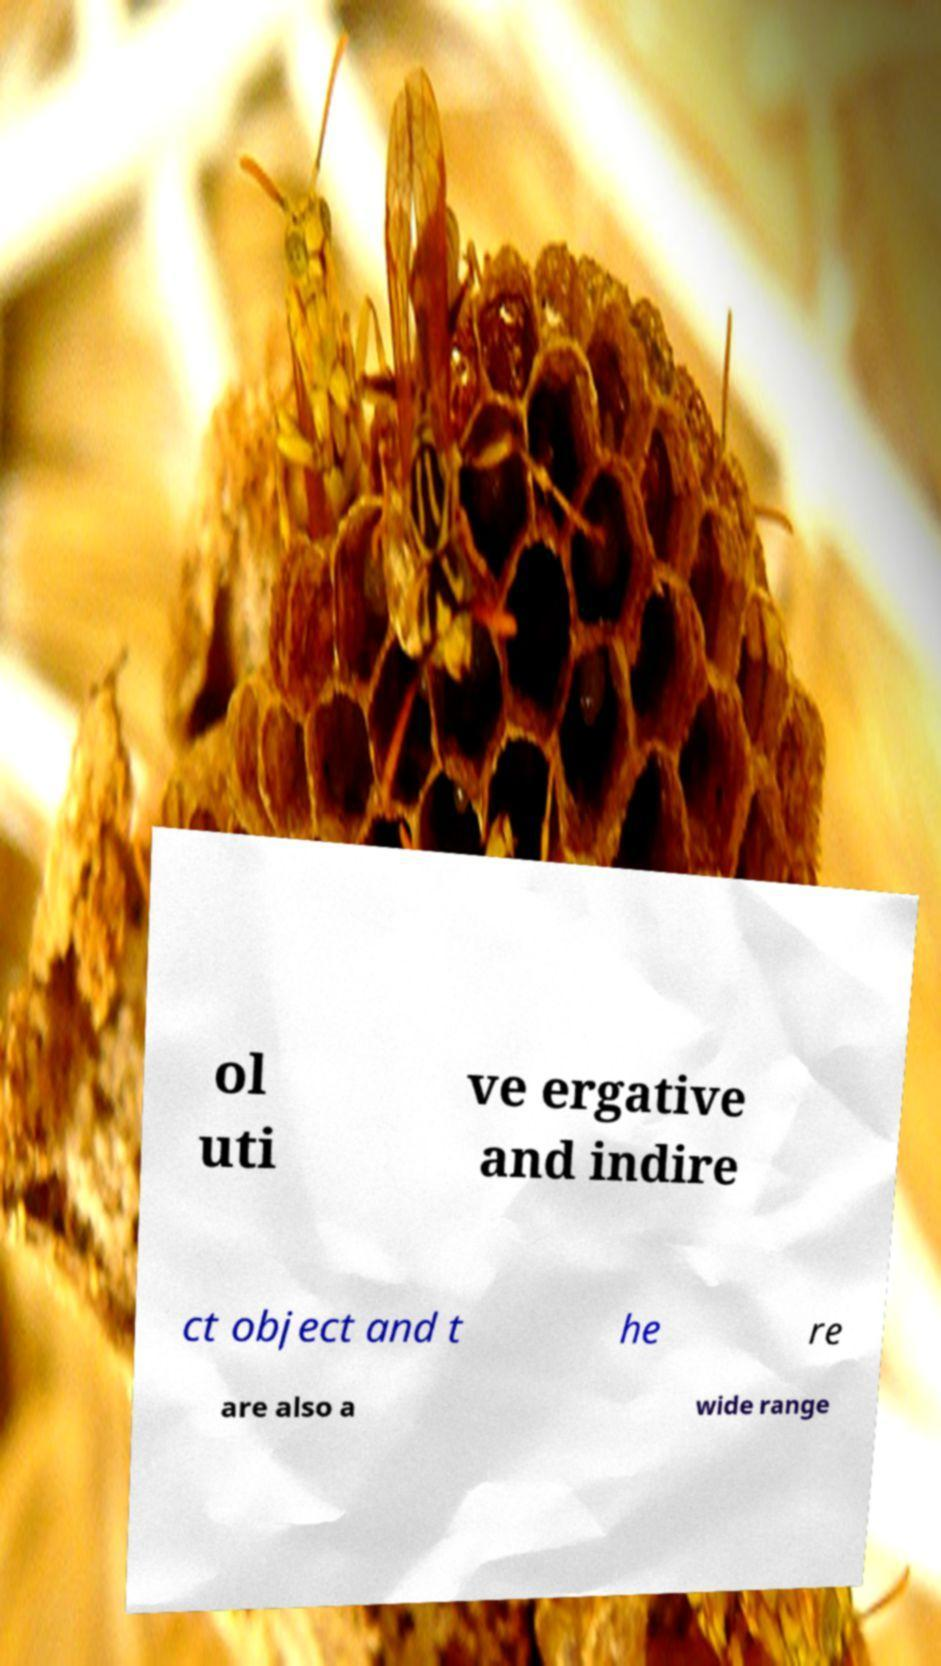Could you extract and type out the text from this image? ol uti ve ergative and indire ct object and t he re are also a wide range 